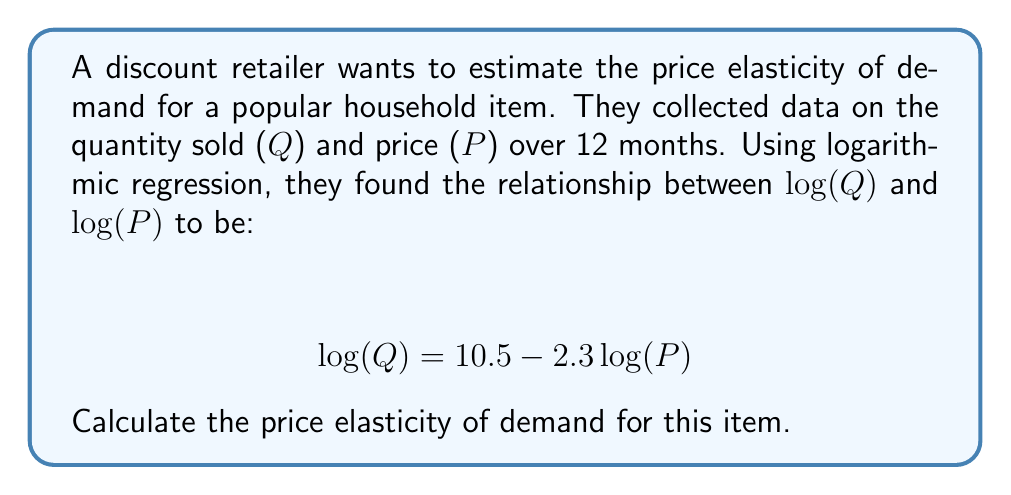Show me your answer to this math problem. To calculate the price elasticity of demand using a logarithmic regression model, we follow these steps:

1. Recall the general form of a log-log regression model:
   $$\log(Q) = \beta_0 + \beta_1\log(P)$$

2. In this case, we have:
   $$\log(Q) = 10.5 - 2.3\log(P)$$

3. The coefficient of $\log(P)$, which is $\beta_1$, represents the price elasticity of demand. This is because in a log-log model, $\beta_1$ gives the percentage change in Q for a 1% change in P.

4. In our equation, $\beta_1 = -2.3$

5. The price elasticity of demand is the absolute value of this coefficient.

Therefore, the price elasticity of demand is $|-2.3| = 2.3$.

Interpretation: For every 1% increase in price, the quantity demanded decreases by approximately 2.3%, and vice versa.
Answer: 2.3 